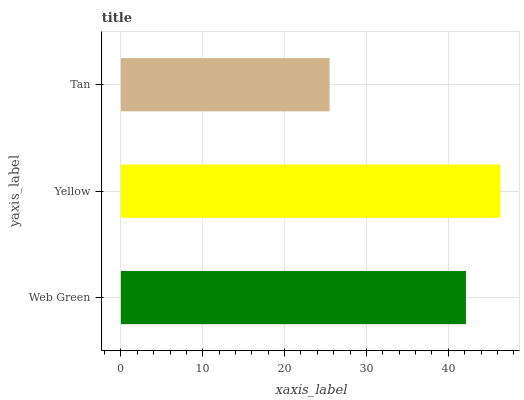Is Tan the minimum?
Answer yes or no. Yes. Is Yellow the maximum?
Answer yes or no. Yes. Is Yellow the minimum?
Answer yes or no. No. Is Tan the maximum?
Answer yes or no. No. Is Yellow greater than Tan?
Answer yes or no. Yes. Is Tan less than Yellow?
Answer yes or no. Yes. Is Tan greater than Yellow?
Answer yes or no. No. Is Yellow less than Tan?
Answer yes or no. No. Is Web Green the high median?
Answer yes or no. Yes. Is Web Green the low median?
Answer yes or no. Yes. Is Yellow the high median?
Answer yes or no. No. Is Yellow the low median?
Answer yes or no. No. 